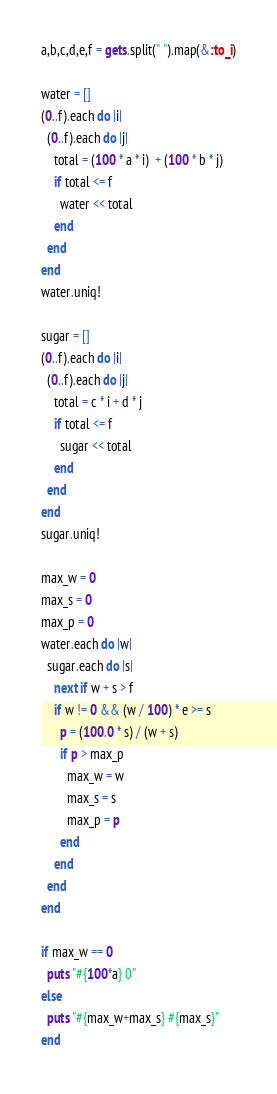<code> <loc_0><loc_0><loc_500><loc_500><_Ruby_>a,b,c,d,e,f = gets.split(" ").map(&:to_i)

water = []
(0..f).each do |i|
  (0..f).each do |j|
    total = (100 * a * i)  + (100 * b * j)
    if total <= f
      water << total
    end
  end
end
water.uniq!

sugar = []
(0..f).each do |i|
  (0..f).each do |j|
    total = c * i + d * j
    if total <= f
      sugar << total
    end
  end
end
sugar.uniq!

max_w = 0
max_s = 0
max_p = 0
water.each do |w|
  sugar.each do |s|
    next if w + s > f
    if w != 0 && (w / 100) * e >= s
      p = (100.0 * s) / (w + s)
      if p > max_p
        max_w = w
        max_s = s
        max_p = p
      end
    end
  end
end

if max_w == 0
  puts "#{100*a} 0"
else
  puts "#{max_w+max_s} #{max_s}"
end</code> 